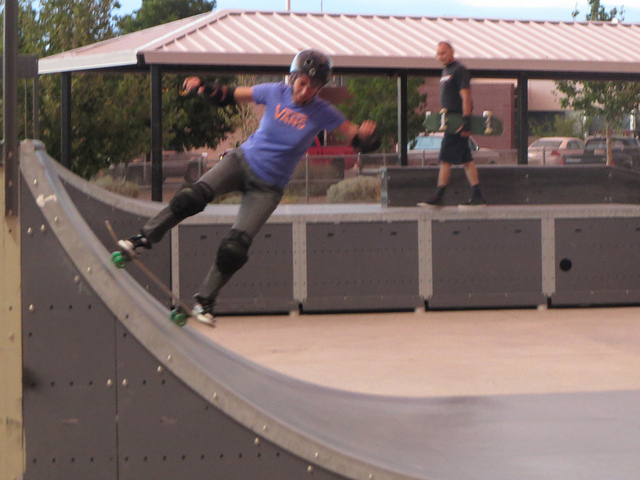Describe a day in the life of this skateboarder. The skateboarder likely starts their day with a healthy breakfast and a warm-up session to prepare for long hours of practice. They spend the morning at the skate park perfecting tricks and techniques, taking short breaks to hydrate and rest. Lunch is a quick, nutritious meal to maintain energy levels. In the afternoon, they might review videos of their performance to identify areas for improvement. The day ends with a cool-down session and some time spent on maintenance of their skateboard. In the evening, they might engage in other hobbies, spend time with family, or watch skateboarding videos for inspiration. Imagine the skateboarder has a magical skateboard. What special abilities does the skateboard have? The magical skateboard can defy gravity, allowing the skateboarder to perform tricks in mid-air with ease. It has a self-repair function that fixes any damage instantly. Additionally, the skateboard can change its size and shape to adapt to different terrains, making it perfect for any kind of trick or stunt. It also has an energy-boosting feature that provides extra speed and agility, ensuring the skateboarder can execute even the most complex maneuvers flawlessly. Can you create a short story about the skateboarding adventure? Tommy, an avid skateboarder, discovered a magical skateboard hidden in the attic. From the moment he stepped on it, his skating skills enhanced dramatically. He found himself performing incredible tricks that defied all laws of physics. One day, he entered an underground skateboarding competition known only to a select few. With the magical skateboard, Tommy dazzled the audience, executing spins and flips mid-air. However, the true challenge came in the form of a final trick that involved skating off a high ramp and landing perfectly on a distant platform. With a deep breath and a rush of adrenaline, Tommy completed the trick flawlessly, winning the competition and the respect of his peers. It was the beginning of a legendary career in skateboarding, all thanks to the magical skateboard. 